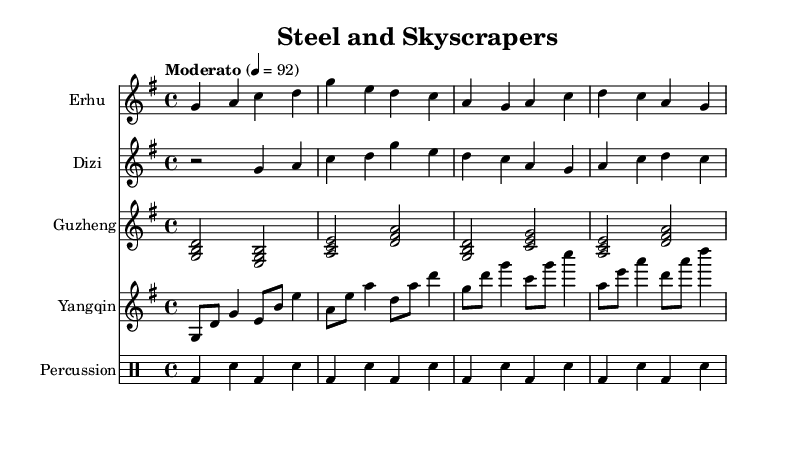What is the title of this piece? The title of the piece is indicated at the top of the sheet music, labeled as "Steel and Skyscrapers."
Answer: Steel and Skyscrapers What is the time signature of this music? The time signature is located after the key signature in the sheet music, and it shows that there are four beats per measure, indicated as 4/4.
Answer: 4/4 What instruments are featured in this score? The score lists several Staves, each labeled with different instruments: Erhu, Dizi, Guzheng, Yangqin, and Percussion, indicating the instruments present.
Answer: Erhu, Dizi, Guzheng, Yangqin, Percussion What is the tempo marking for the piece? The tempo marking is present at the beginning and indicates a speed of "Moderato" at a tempo of 92 beats per minute.
Answer: Moderato, 92 How many measures are there in the percussion part? By counting each complete set of the drum notation, it can be observed that there are eight measures in the percussion part.
Answer: Eight How does the instrumentation reflect traditional Chinese music? The use of traditional instruments like Erhu, Dizi, Guzheng, and Yangqin showcases the characteristics of traditional Chinese music while contributing to a modern urban context. This blend signifies the cultural transition during the 1990s.
Answer: Traditional instruments What is the main theme conveyed through the combination of instruments? The instruments play melodic lines and harmonies that symbolize both the serene elements of traditional folk music and the dynamic changes of the urban landscape, suggesting a tension between tradition and modernity.
Answer: Tradition and modernity 